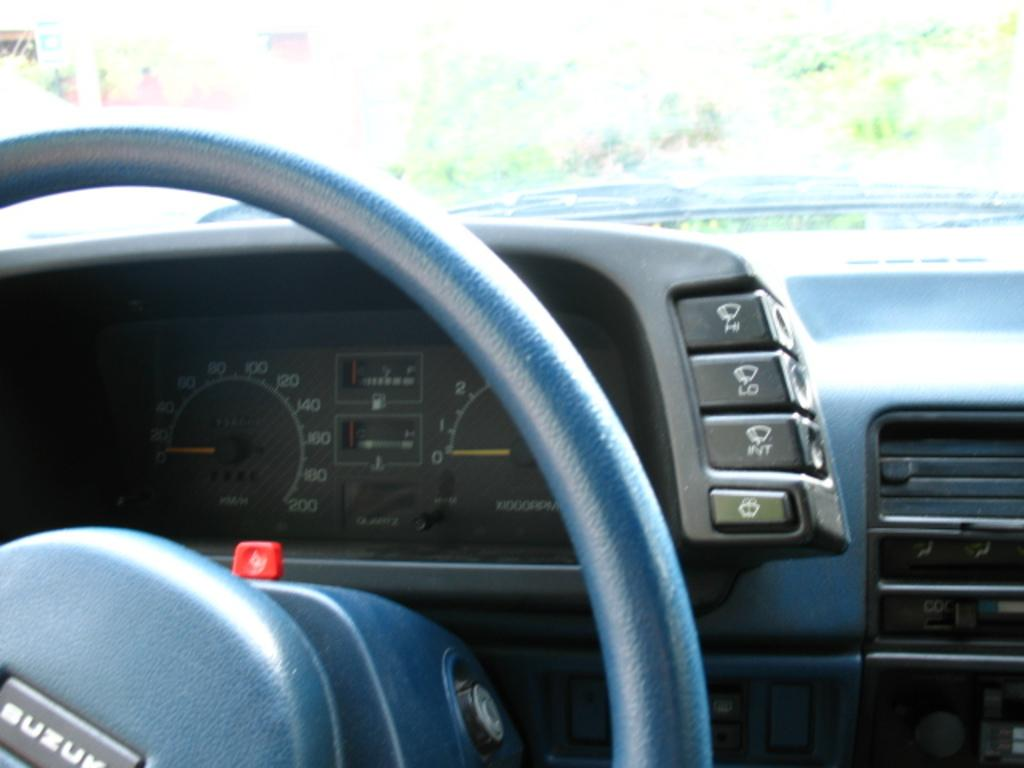What type of space is shown in the image? The image shows the inside of a vehicle. What is the primary control device in the vehicle? There is a steering wheel in the vehicle. How can the driver monitor their speed in the vehicle? There are speedometers in the vehicle. Can you describe any other objects visible in the vehicle? There are other objects visible in the vehicle, but their specific details are not mentioned in the provided facts. How would you describe the background of the image? The background of the image is blurry. Who is the manager of the hydrant seen in the image? There is no hydrant present in the image, so there is no manager to discuss. 